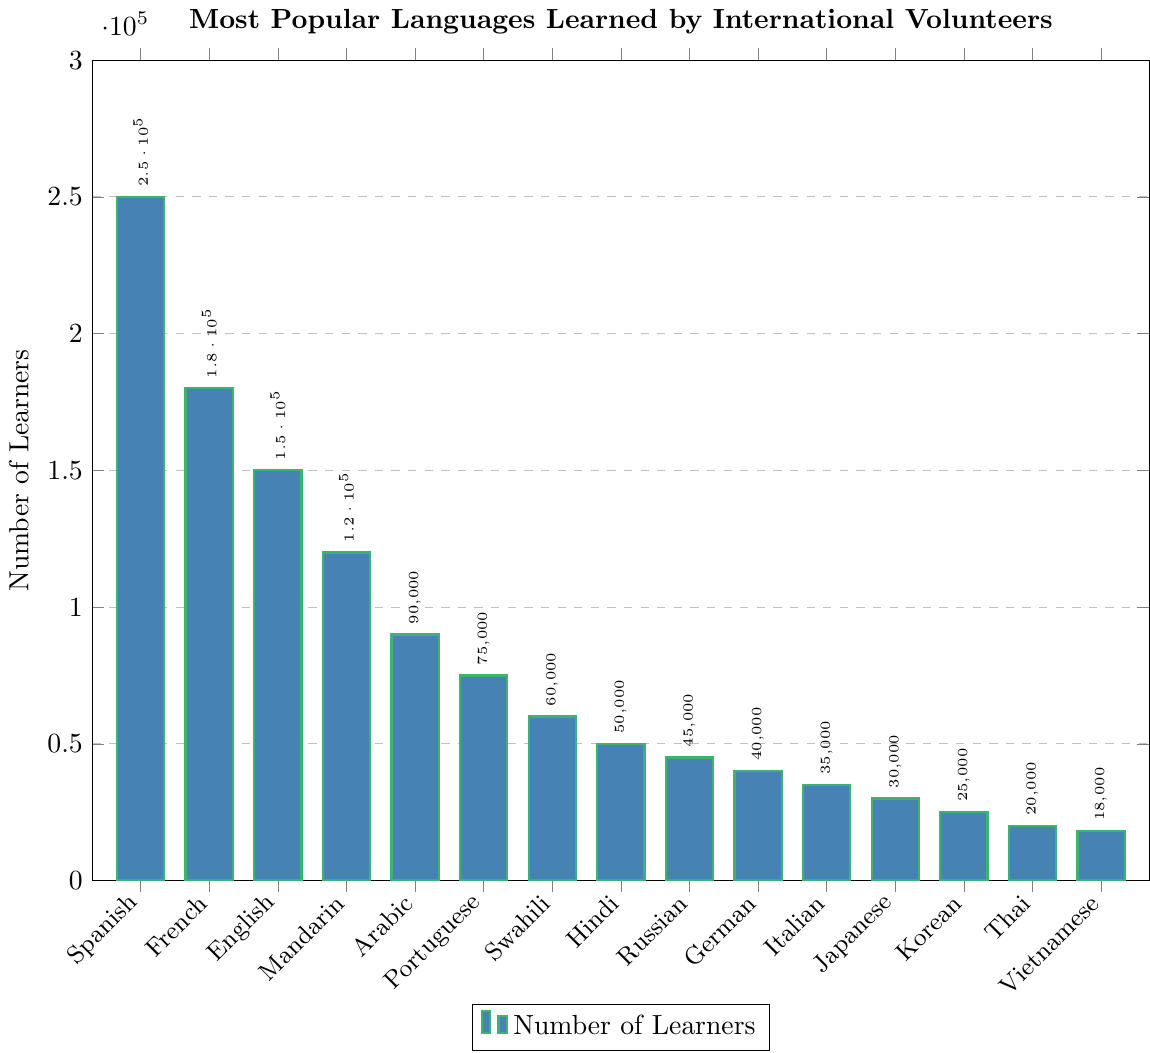What language is learned by the highest number of international volunteers? By examining the height of the bars, the tallest bar represents Spanish, showing it is the most learned language.
Answer: Spanish Which two languages have the smallest difference in the number of learners? We need to examine the bars with the smallest difference in their heights. Swahili and Hindi have the smallest difference, with 60,000 and 50,000 learners respectively, a difference of 10,000 learners.
Answer: Swahili and Hindi How many more volunteers learn Spanish compared to German? Find the heights of the bars for Spanish (250,000) and German (40,000), then subtract the number of German learners from Spanish learners: 250,000 - 40,000.
Answer: 210,000 Which language has more learners, Mandarin Chinese or Portuguese, and by how many? Compare the heights of the bars for Mandarin Chinese (120,000) and Portuguese (75,000). Subtract the number of Portuguese learners from Mandarin Chinese learners: 120,000 - 75,000.
Answer: Mandarin Chinese by 45,000 What is the combined number of learners for the three least popular languages? Identify the three shortest bars for Thai (20,000), Vietnamese (18,000), and Korean (25,000). Sum their heights: 20,000 + 18,000 + 25,000.
Answer: 63,000 Which is more popular among international volunteers: French or Arabic? By comparing the heights of the French (180,000) and Arabic (90,000) bars, it is clear that French is more popular.
Answer: French What is the total number of learners for all the languages shown? Sum the heights of each bar: 250,000 + 180,000 + 150,000 + 120,000 + 90,000 + 75,000 + 60,000 + 50,000 + 45,000 + 40,000 + 35,000 + 30,000 + 25,000 + 20,000 + 18,000.
Answer: 1,188,000 Which language has the fifth highest number of learners? Rank the languages by the height of their bars from highest to lowest: Spanish, French, English, Mandarin Chinese, and then Arabic.
Answer: Arabic Among the top six languages, what is the average number of learners? Identify the top six languages: Spanish (250,000), French (180,000), English (150,000), Mandarin Chinese (120,000), Arabic (90,000), Portuguese (75,000). Calculate the sum: 250,000 + 180,000 + 150,000 + 120,000 + 90,000 + 75,000 = 865,000. Divide by 6 to find the average: 865,000 / 6.
Answer: 144,167 What percentage of the total number of learners does the Spanish bar represent? Calculate the total number of learners: 1,188,000. Spanish learners are 250,000. Use the formula (Spanish learners / Total learners) * 100: (250,000 / 1,188,000) * 100.
Answer: approx. 21% 